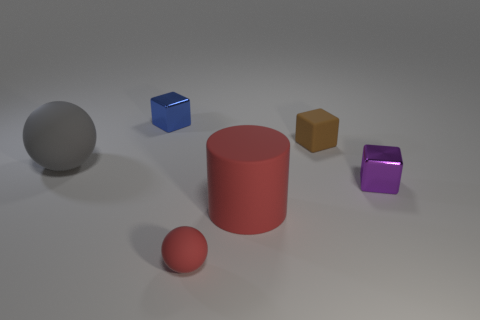There is another block that is the same material as the tiny purple cube; what size is it?
Offer a very short reply. Small. What number of gray things have the same shape as the blue object?
Your answer should be very brief. 0. Are there more cylinders that are behind the small purple metallic object than gray rubber spheres behind the blue thing?
Provide a succinct answer. No. There is a big cylinder; is it the same color as the object that is in front of the big red cylinder?
Offer a terse response. Yes. There is a brown block that is the same size as the purple metallic cube; what material is it?
Give a very brief answer. Rubber. How many objects are large red spheres or big rubber objects on the right side of the small red rubber object?
Provide a short and direct response. 1. Does the purple block have the same size as the matte ball to the left of the blue metallic cube?
Your response must be concise. No. How many balls are big rubber objects or tiny purple metallic objects?
Your answer should be compact. 1. What number of things are both behind the red rubber ball and in front of the small blue metallic object?
Keep it short and to the point. 4. What number of other objects are there of the same color as the small rubber block?
Ensure brevity in your answer.  0. 